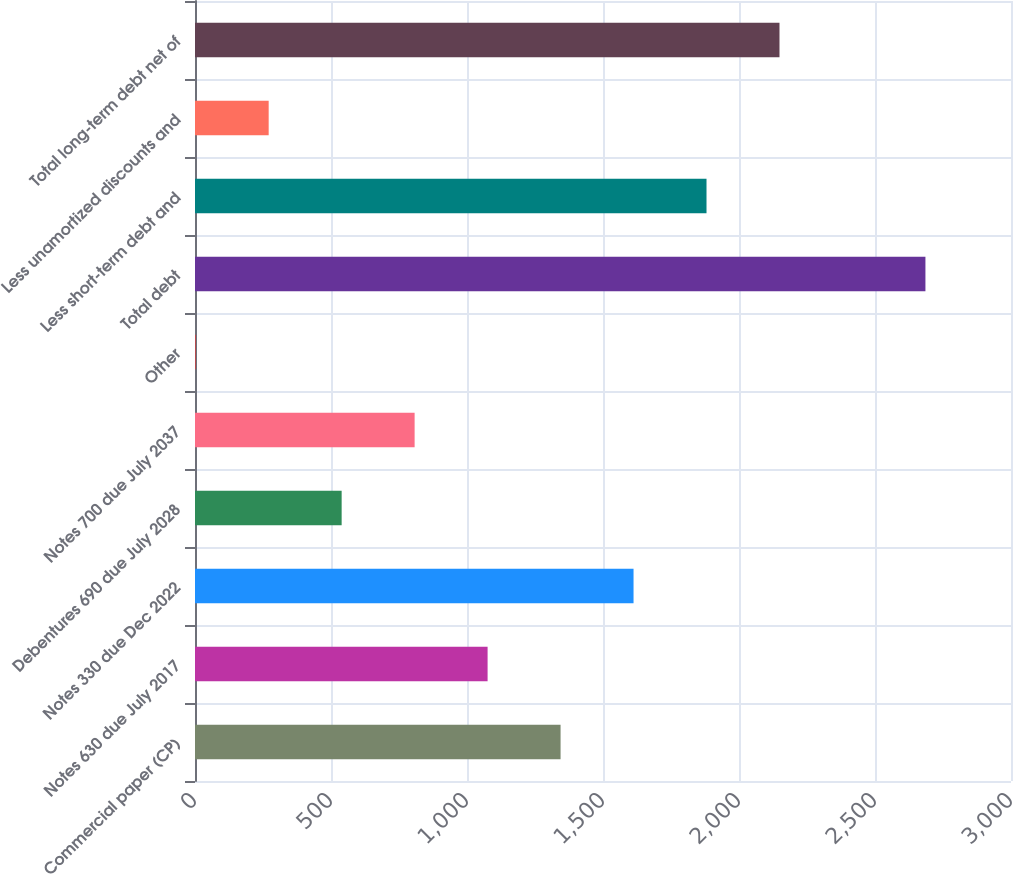Convert chart. <chart><loc_0><loc_0><loc_500><loc_500><bar_chart><fcel>Commercial paper (CP)<fcel>Notes 630 due July 2017<fcel>Notes 330 due Dec 2022<fcel>Debentures 690 due July 2028<fcel>Notes 700 due July 2037<fcel>Other<fcel>Total debt<fcel>Less short-term debt and<fcel>Less unamortized discounts and<fcel>Total long-term debt net of<nl><fcel>1344<fcel>1075.72<fcel>1612.28<fcel>539.16<fcel>807.44<fcel>2.6<fcel>2685.4<fcel>1880.56<fcel>270.88<fcel>2148.84<nl></chart> 